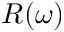Convert formula to latex. <formula><loc_0><loc_0><loc_500><loc_500>R ( \omega )</formula> 